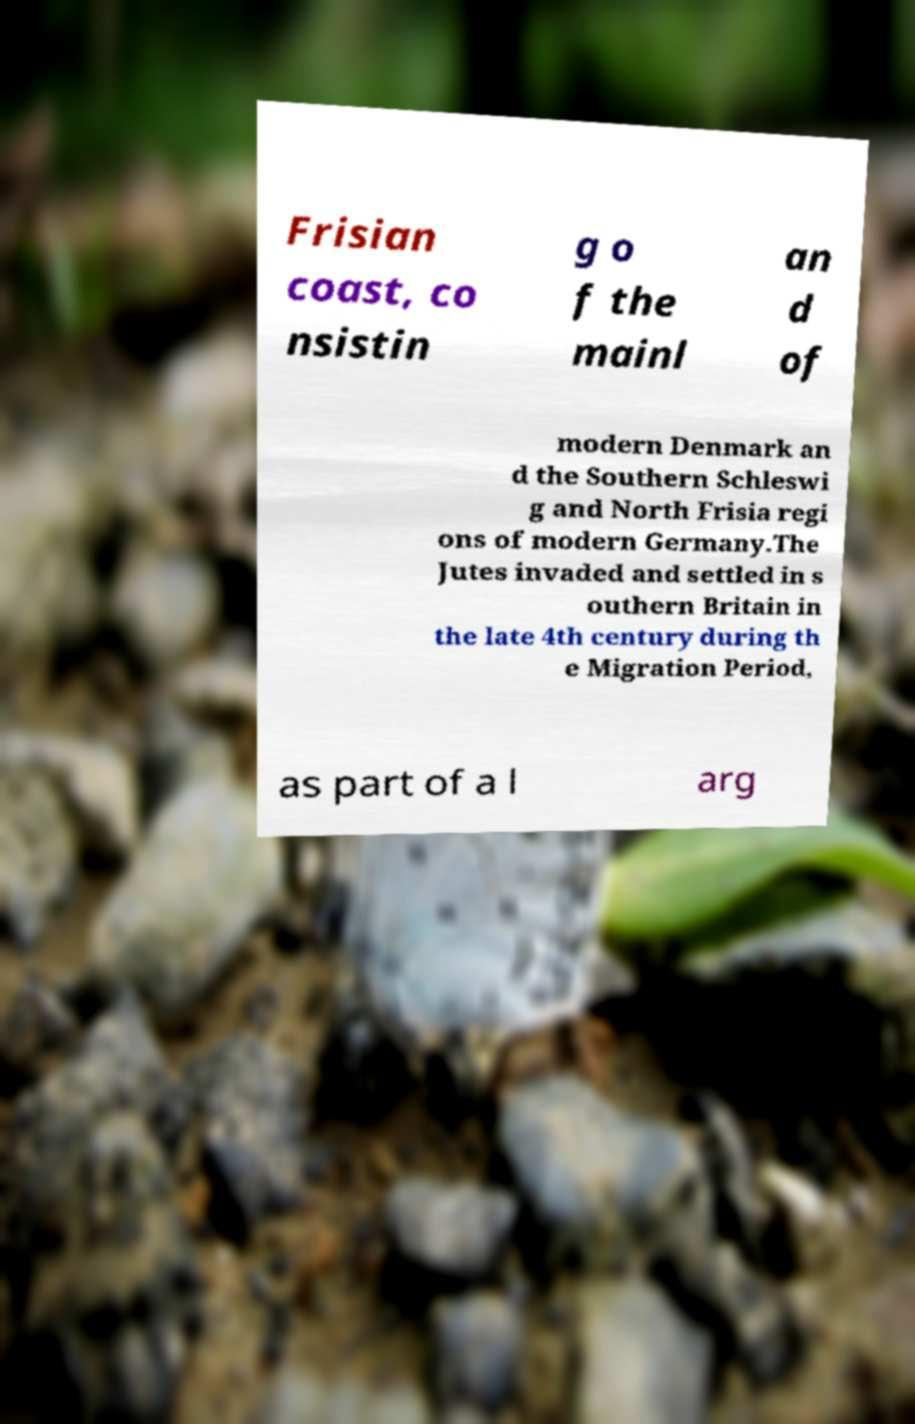Can you accurately transcribe the text from the provided image for me? Frisian coast, co nsistin g o f the mainl an d of modern Denmark an d the Southern Schleswi g and North Frisia regi ons of modern Germany.The Jutes invaded and settled in s outhern Britain in the late 4th century during th e Migration Period, as part of a l arg 